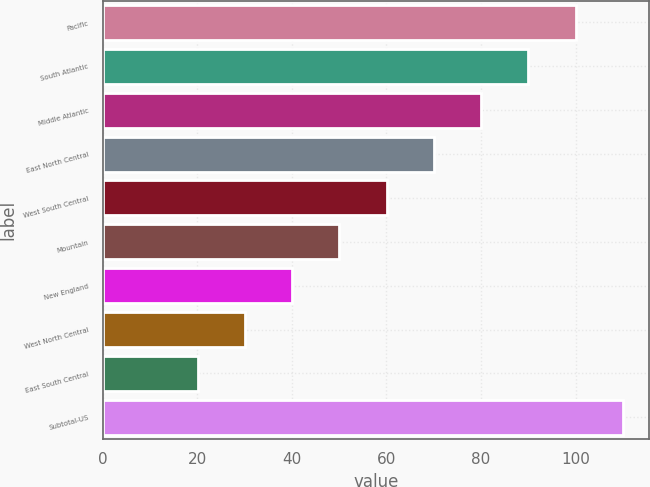Convert chart to OTSL. <chart><loc_0><loc_0><loc_500><loc_500><bar_chart><fcel>Pacific<fcel>South Atlantic<fcel>Middle Atlantic<fcel>East North Central<fcel>West South Central<fcel>Mountain<fcel>New England<fcel>West North Central<fcel>East South Central<fcel>Subtotal-US<nl><fcel>100<fcel>90.01<fcel>80.02<fcel>70.03<fcel>60.04<fcel>50.05<fcel>40.06<fcel>30.07<fcel>20.08<fcel>109.99<nl></chart> 